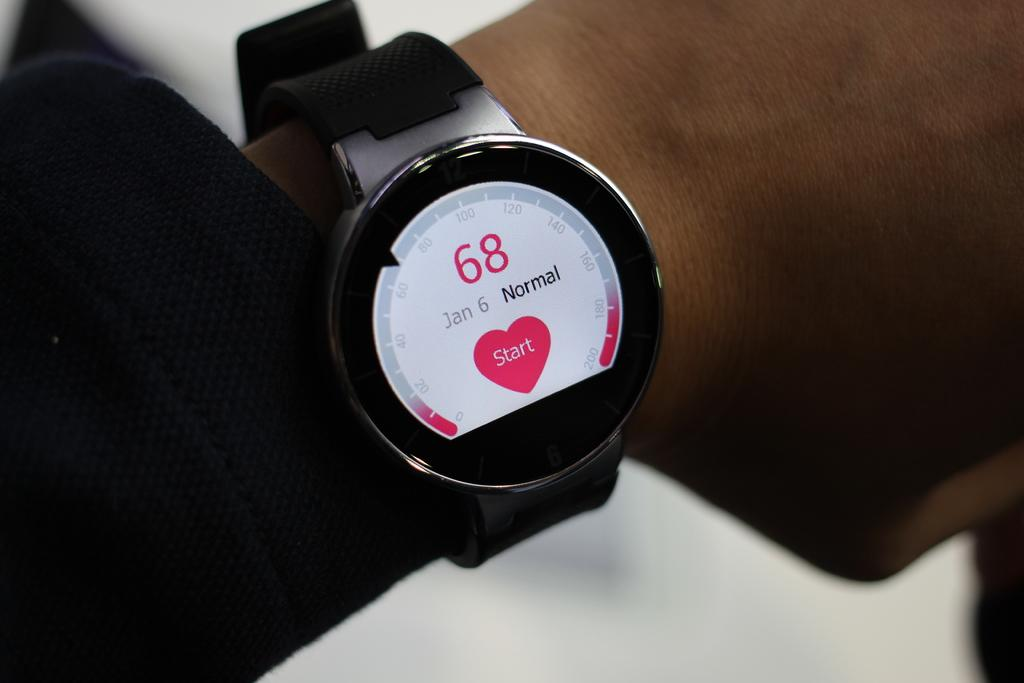<image>
Present a compact description of the photo's key features. Person looking at a wristwatch that says the number 68 on it. 